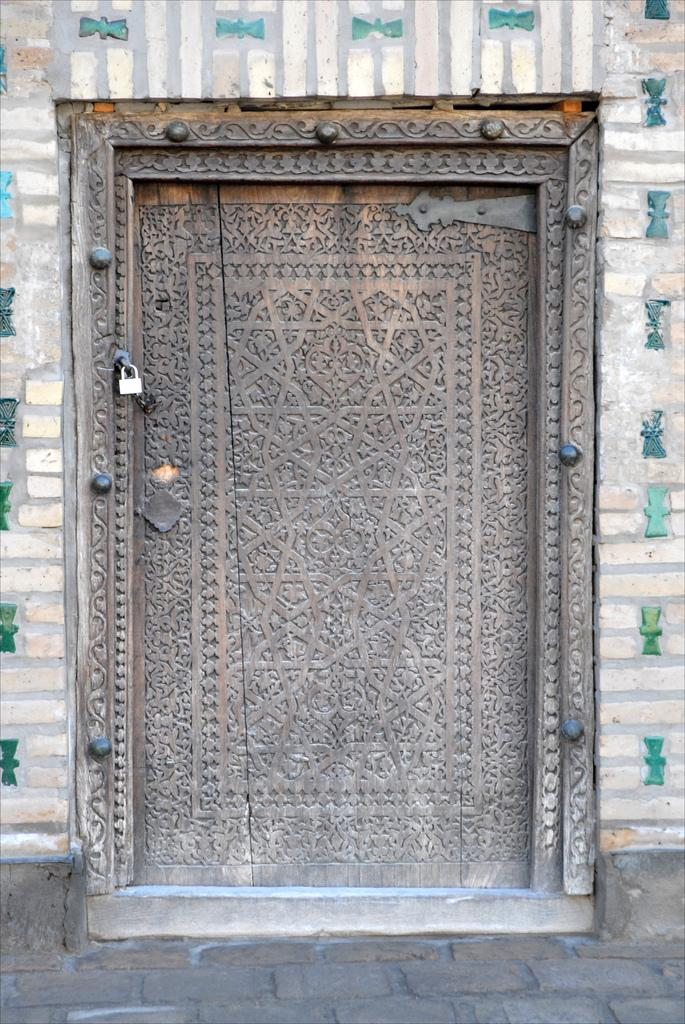What is the main object in the image? There is a door in the image. What is the status of the door? The door is locked. What else can be seen in the image besides the door? There is a wall visible in the image. What type of treatment is being administered to the plantation in the image? There is no plantation present in the image, and therefore no treatment can be administered. 